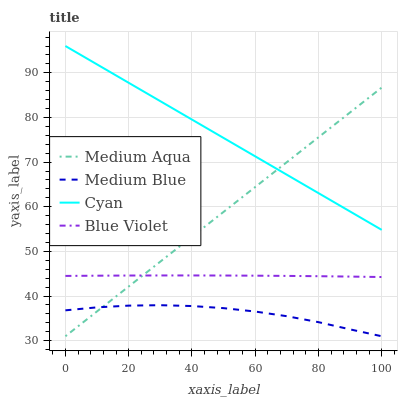Does Medium Aqua have the minimum area under the curve?
Answer yes or no. No. Does Medium Aqua have the maximum area under the curve?
Answer yes or no. No. Is Medium Aqua the smoothest?
Answer yes or no. No. Is Medium Aqua the roughest?
Answer yes or no. No. Does Blue Violet have the lowest value?
Answer yes or no. No. Does Medium Aqua have the highest value?
Answer yes or no. No. Is Medium Blue less than Blue Violet?
Answer yes or no. Yes. Is Cyan greater than Medium Blue?
Answer yes or no. Yes. Does Medium Blue intersect Blue Violet?
Answer yes or no. No. 